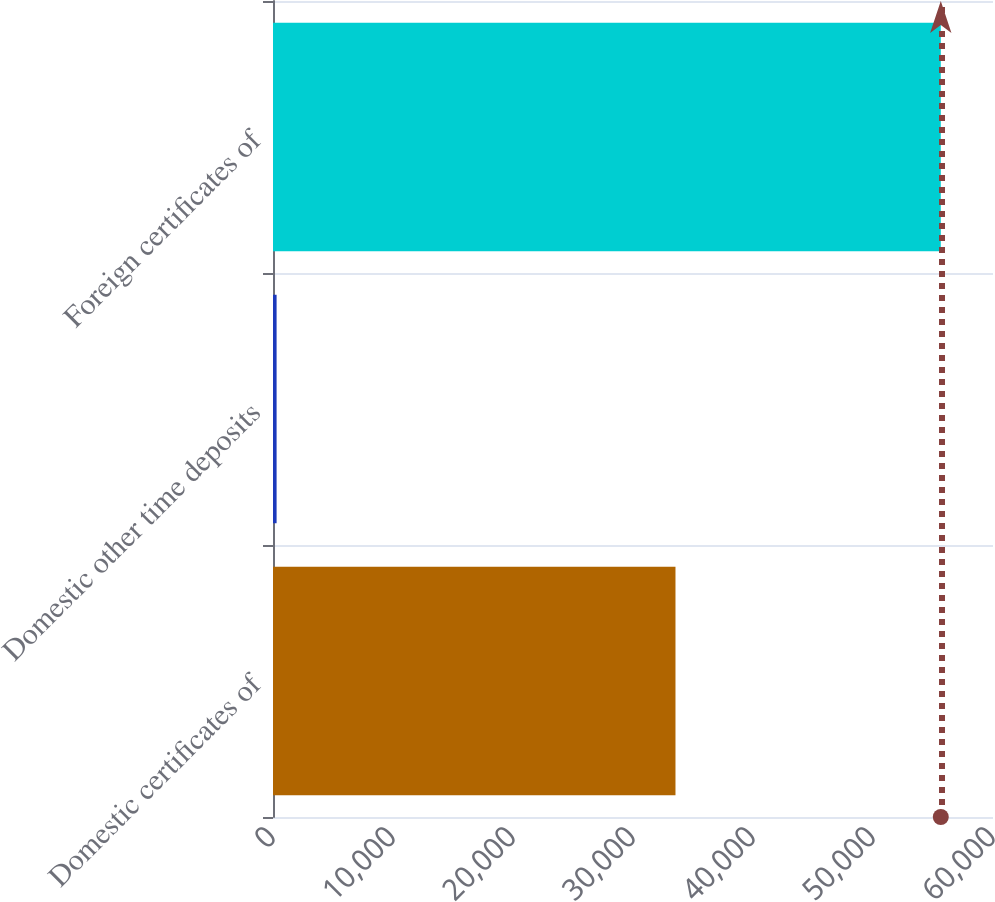Convert chart to OTSL. <chart><loc_0><loc_0><loc_500><loc_500><bar_chart><fcel>Domestic certificates of<fcel>Domestic other time deposits<fcel>Foreign certificates of<nl><fcel>33540<fcel>300<fcel>55649<nl></chart> 